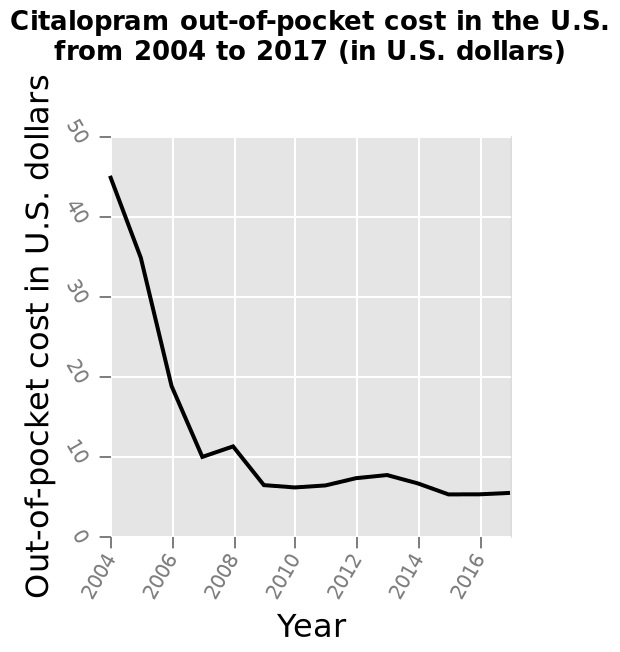<image>
please summary the statistics and relations of the chart Out of pocket cost falls from 2004-2007The costs rise again from 2007-2008The cost remains relatively strable after 2008. What does the x-axis represent in the line diagram?  The x-axis represents the years from 2004 to 2017. What happened to the out of pocket cost from 2004 to 2007?  The out of pocket cost fell from 2004 to 2007. 